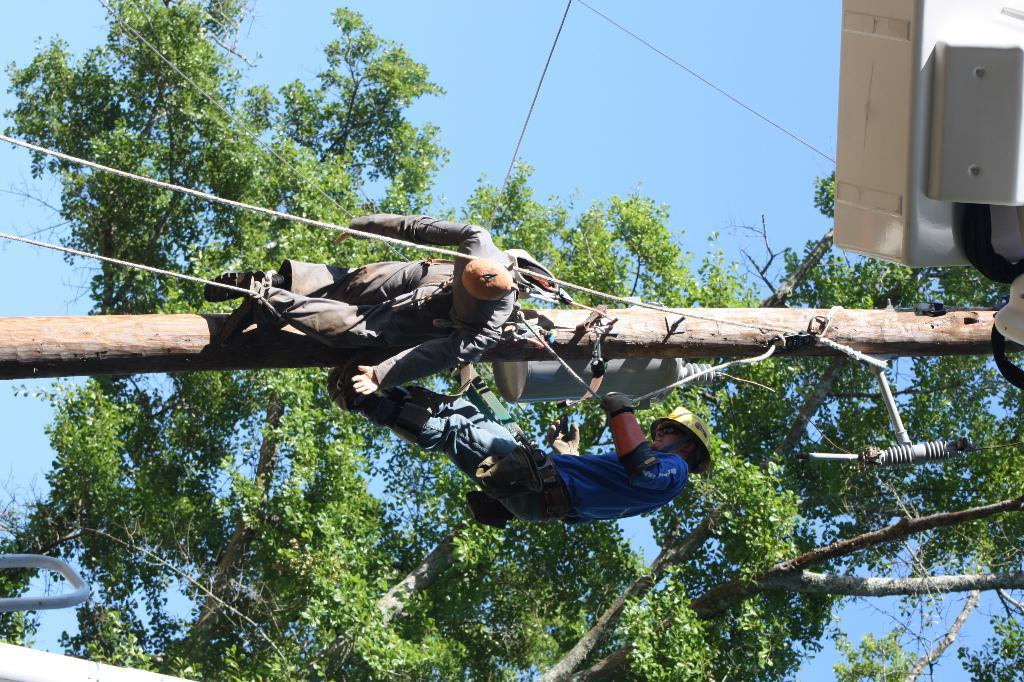What are the people in the image doing? The people in the image are standing on an electric pole. What safety precaution are the people taking? The people are wearing helmets. What can be seen in the background of the image? There is a tree visible in the background of the image. What type of feast is being prepared in the image? There is no feast being prepared in the image; it features people standing on an electric pole. What kind of ship can be seen sailing in the background of the image? There is no ship visible in the image; it only shows people on an electric pole and a tree in the background. 